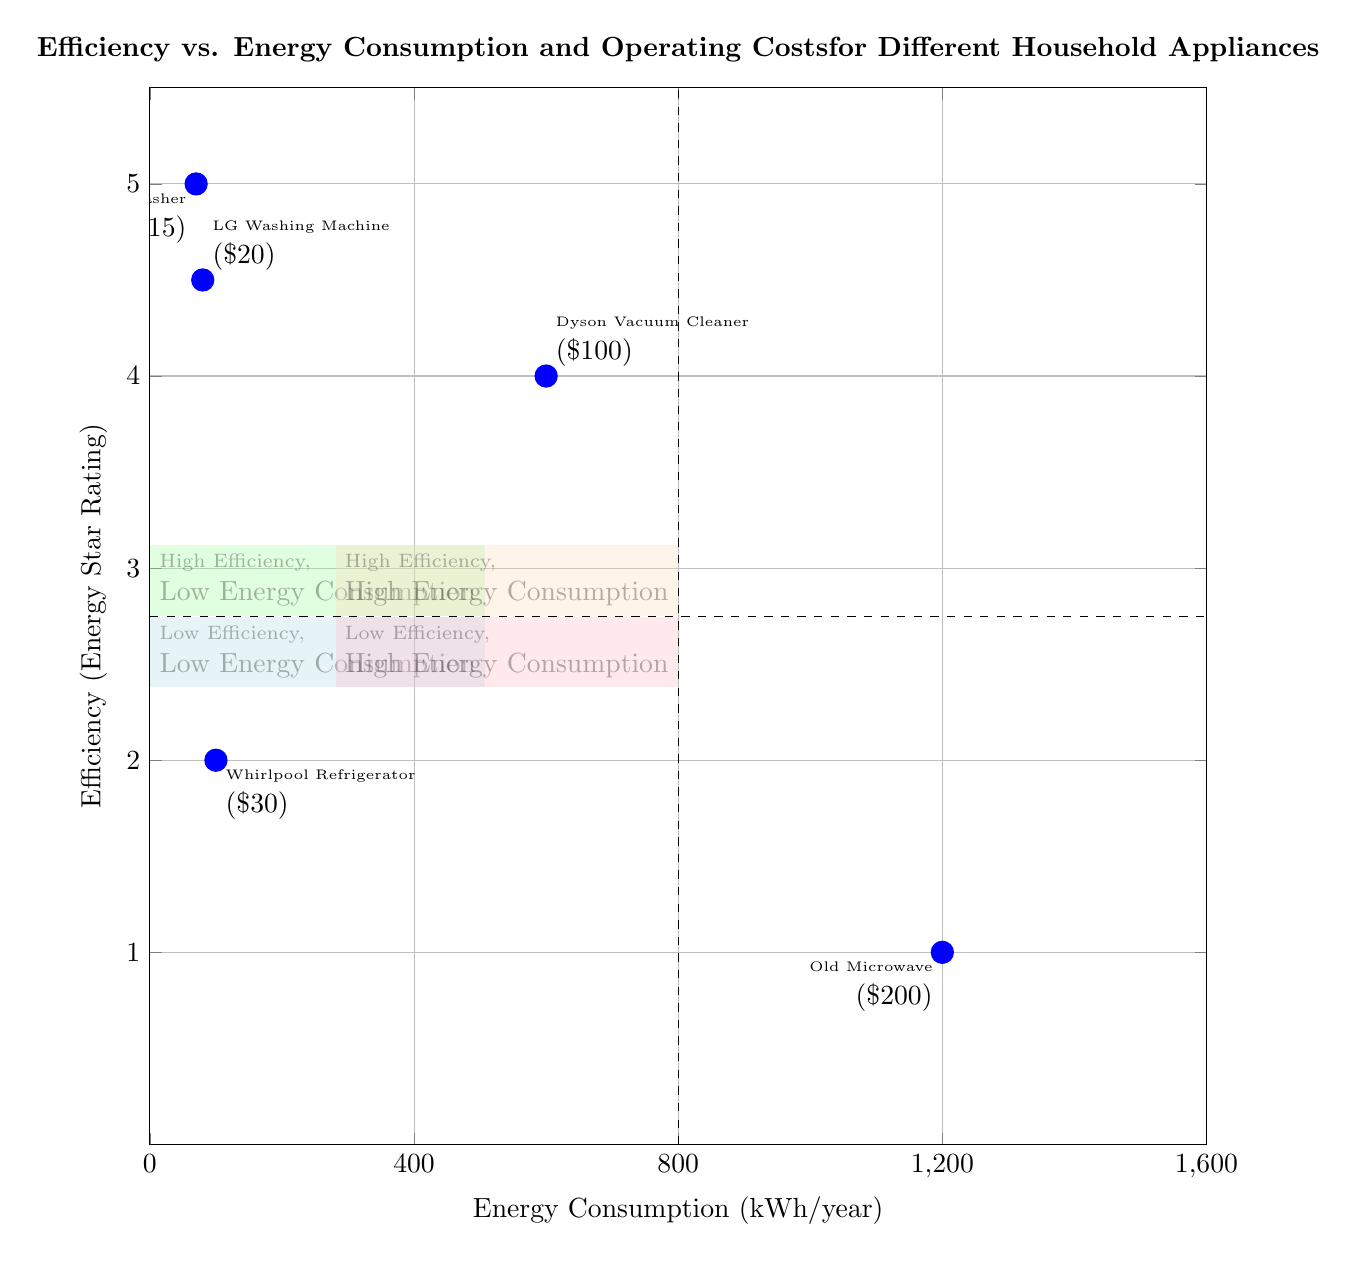What is the efficiency rating of the Bosch Dishwasher? The Bosch Dishwasher is located in the "High Efficiency, Low Energy Consumption" quadrant, where the appliances are labeled with their efficiency ratings. The Bosch Dishwasher has an efficiency rating of 5.
Answer: 5 How much energy does the Dyson Vacuum Cleaner consume per year? The Dyson Vacuum Cleaner is found in the "High Efficiency, High Energy Consumption" quadrant. Its energy consumption is marked as 600 kWh/year.
Answer: 600 kWh/year Which appliance has the lowest operating cost? By reviewing the listed operating costs next to each appliance, the Bosch Dishwasher has the lowest operating cost at $15, compared to the others.
Answer: $15 Which quadrant contains appliances with both high efficiency and low energy consumption? The quadrant titled "High Efficiency, Low Energy Consumption" contains appliances that are efficient and consume less energy. This quadrant can be identified on the bottom left side of the diagram.
Answer: High Efficiency, Low Energy Consumption How many appliances are listed in the "Low Efficiency, High Energy Consumption" quadrant? The "Low Efficiency, High Energy Consumption" quadrant has only one appliance mentioned, which is the Old Microwave. Therefore, the count is one.
Answer: 1 What is the operating cost of the Whirlpool Refrigerator? The Whirlpool Refrigerator is located in the "Low Efficiency, Low Energy Consumption" quadrant, and it is noted to have an operating cost of $30.
Answer: $30 Which appliance is located in the "Low Efficiency, Low Energy Consumption" quadrant? The only appliance listed in this quadrant is the Whirlpool Refrigerator, which is specifically identified in the diagram.
Answer: Whirlpool Refrigerator What is the relationship between energy consumption and operating costs for the Old Microwave? The Old Microwave in the "Low Efficiency, High Energy Consumption" quadrant consumes a lot of energy at 1200 kWh/year with a high operating cost of $200, illustrating the negative relationship between high consumption and cost.
Answer: High energy consumption leads to high operating costs What is the range of energy consumption indicated on the x-axis? The x-axis of the diagram represents energy consumption ranging from 50 kWh/year to 1500 kWh/year, as labeled clearly on the axis.
Answer: 50 to 1500 kWh/year 